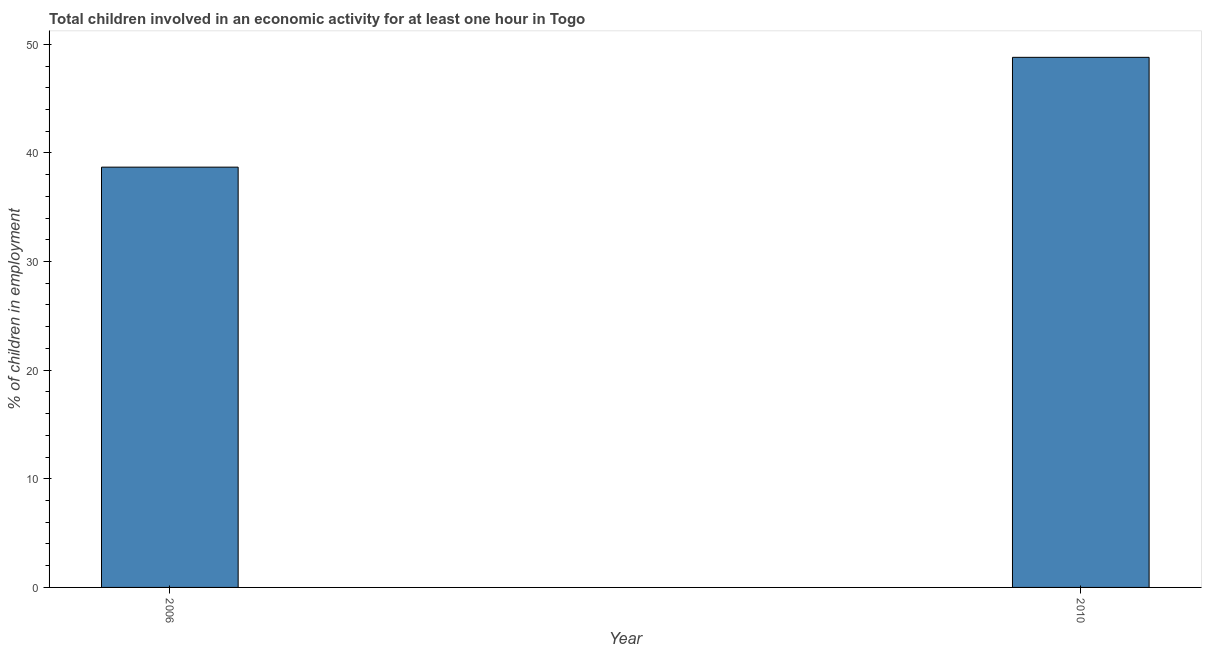What is the title of the graph?
Give a very brief answer. Total children involved in an economic activity for at least one hour in Togo. What is the label or title of the X-axis?
Provide a short and direct response. Year. What is the label or title of the Y-axis?
Ensure brevity in your answer.  % of children in employment. What is the percentage of children in employment in 2010?
Provide a short and direct response. 48.8. Across all years, what is the maximum percentage of children in employment?
Your response must be concise. 48.8. Across all years, what is the minimum percentage of children in employment?
Give a very brief answer. 38.69. In which year was the percentage of children in employment maximum?
Keep it short and to the point. 2010. In which year was the percentage of children in employment minimum?
Ensure brevity in your answer.  2006. What is the sum of the percentage of children in employment?
Make the answer very short. 87.49. What is the difference between the percentage of children in employment in 2006 and 2010?
Your response must be concise. -10.11. What is the average percentage of children in employment per year?
Your answer should be compact. 43.74. What is the median percentage of children in employment?
Make the answer very short. 43.74. In how many years, is the percentage of children in employment greater than 8 %?
Give a very brief answer. 2. Do a majority of the years between 2006 and 2010 (inclusive) have percentage of children in employment greater than 32 %?
Make the answer very short. Yes. What is the ratio of the percentage of children in employment in 2006 to that in 2010?
Provide a succinct answer. 0.79. Is the percentage of children in employment in 2006 less than that in 2010?
Provide a succinct answer. Yes. In how many years, is the percentage of children in employment greater than the average percentage of children in employment taken over all years?
Your answer should be compact. 1. How many bars are there?
Ensure brevity in your answer.  2. Are all the bars in the graph horizontal?
Provide a short and direct response. No. How many years are there in the graph?
Give a very brief answer. 2. What is the % of children in employment of 2006?
Make the answer very short. 38.69. What is the % of children in employment in 2010?
Your answer should be very brief. 48.8. What is the difference between the % of children in employment in 2006 and 2010?
Make the answer very short. -10.11. What is the ratio of the % of children in employment in 2006 to that in 2010?
Your answer should be compact. 0.79. 